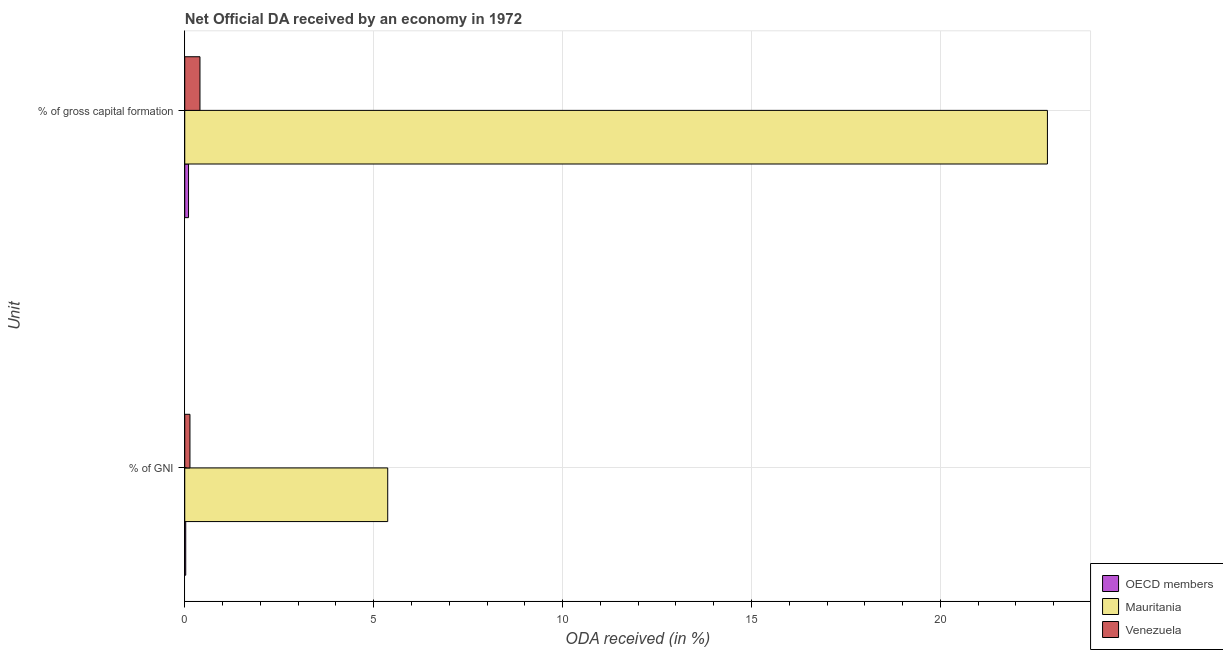How many different coloured bars are there?
Your answer should be compact. 3. How many bars are there on the 1st tick from the top?
Offer a terse response. 3. What is the label of the 2nd group of bars from the top?
Keep it short and to the point. % of GNI. What is the oda received as percentage of gross capital formation in OECD members?
Provide a succinct answer. 0.1. Across all countries, what is the maximum oda received as percentage of gross capital formation?
Your answer should be compact. 22.83. Across all countries, what is the minimum oda received as percentage of gross capital formation?
Make the answer very short. 0.1. In which country was the oda received as percentage of gni maximum?
Keep it short and to the point. Mauritania. In which country was the oda received as percentage of gross capital formation minimum?
Ensure brevity in your answer.  OECD members. What is the total oda received as percentage of gross capital formation in the graph?
Keep it short and to the point. 23.33. What is the difference between the oda received as percentage of gni in OECD members and that in Mauritania?
Provide a succinct answer. -5.35. What is the difference between the oda received as percentage of gross capital formation in Mauritania and the oda received as percentage of gni in OECD members?
Offer a very short reply. 22.81. What is the average oda received as percentage of gni per country?
Your answer should be compact. 1.85. What is the difference between the oda received as percentage of gross capital formation and oda received as percentage of gni in Venezuela?
Offer a very short reply. 0.26. What is the ratio of the oda received as percentage of gross capital formation in Mauritania to that in Venezuela?
Offer a very short reply. 56.71. Is the oda received as percentage of gross capital formation in Venezuela less than that in Mauritania?
Offer a terse response. Yes. In how many countries, is the oda received as percentage of gross capital formation greater than the average oda received as percentage of gross capital formation taken over all countries?
Offer a terse response. 1. What does the 2nd bar from the top in % of gross capital formation represents?
Provide a succinct answer. Mauritania. What does the 1st bar from the bottom in % of GNI represents?
Keep it short and to the point. OECD members. How many bars are there?
Make the answer very short. 6. Are all the bars in the graph horizontal?
Your response must be concise. Yes. How many countries are there in the graph?
Provide a short and direct response. 3. What is the difference between two consecutive major ticks on the X-axis?
Make the answer very short. 5. Are the values on the major ticks of X-axis written in scientific E-notation?
Your answer should be compact. No. How are the legend labels stacked?
Provide a short and direct response. Vertical. What is the title of the graph?
Your answer should be compact. Net Official DA received by an economy in 1972. Does "Djibouti" appear as one of the legend labels in the graph?
Your response must be concise. No. What is the label or title of the X-axis?
Provide a succinct answer. ODA received (in %). What is the label or title of the Y-axis?
Offer a terse response. Unit. What is the ODA received (in %) of OECD members in % of GNI?
Your response must be concise. 0.03. What is the ODA received (in %) in Mauritania in % of GNI?
Keep it short and to the point. 5.37. What is the ODA received (in %) in Venezuela in % of GNI?
Provide a short and direct response. 0.14. What is the ODA received (in %) in OECD members in % of gross capital formation?
Give a very brief answer. 0.1. What is the ODA received (in %) of Mauritania in % of gross capital formation?
Your answer should be compact. 22.83. What is the ODA received (in %) in Venezuela in % of gross capital formation?
Give a very brief answer. 0.4. Across all Unit, what is the maximum ODA received (in %) of OECD members?
Provide a short and direct response. 0.1. Across all Unit, what is the maximum ODA received (in %) of Mauritania?
Offer a very short reply. 22.83. Across all Unit, what is the maximum ODA received (in %) of Venezuela?
Provide a succinct answer. 0.4. Across all Unit, what is the minimum ODA received (in %) of OECD members?
Give a very brief answer. 0.03. Across all Unit, what is the minimum ODA received (in %) of Mauritania?
Your answer should be compact. 5.37. Across all Unit, what is the minimum ODA received (in %) of Venezuela?
Provide a succinct answer. 0.14. What is the total ODA received (in %) of OECD members in the graph?
Give a very brief answer. 0.13. What is the total ODA received (in %) in Mauritania in the graph?
Keep it short and to the point. 28.2. What is the total ODA received (in %) of Venezuela in the graph?
Offer a very short reply. 0.54. What is the difference between the ODA received (in %) in OECD members in % of GNI and that in % of gross capital formation?
Provide a short and direct response. -0.07. What is the difference between the ODA received (in %) in Mauritania in % of GNI and that in % of gross capital formation?
Your response must be concise. -17.46. What is the difference between the ODA received (in %) of Venezuela in % of GNI and that in % of gross capital formation?
Your answer should be compact. -0.27. What is the difference between the ODA received (in %) of OECD members in % of GNI and the ODA received (in %) of Mauritania in % of gross capital formation?
Make the answer very short. -22.81. What is the difference between the ODA received (in %) of OECD members in % of GNI and the ODA received (in %) of Venezuela in % of gross capital formation?
Your answer should be very brief. -0.38. What is the difference between the ODA received (in %) of Mauritania in % of GNI and the ODA received (in %) of Venezuela in % of gross capital formation?
Offer a very short reply. 4.97. What is the average ODA received (in %) of OECD members per Unit?
Offer a very short reply. 0.06. What is the average ODA received (in %) of Mauritania per Unit?
Provide a succinct answer. 14.1. What is the average ODA received (in %) of Venezuela per Unit?
Your answer should be very brief. 0.27. What is the difference between the ODA received (in %) of OECD members and ODA received (in %) of Mauritania in % of GNI?
Give a very brief answer. -5.35. What is the difference between the ODA received (in %) of OECD members and ODA received (in %) of Venezuela in % of GNI?
Provide a succinct answer. -0.11. What is the difference between the ODA received (in %) in Mauritania and ODA received (in %) in Venezuela in % of GNI?
Keep it short and to the point. 5.23. What is the difference between the ODA received (in %) of OECD members and ODA received (in %) of Mauritania in % of gross capital formation?
Ensure brevity in your answer.  -22.73. What is the difference between the ODA received (in %) in OECD members and ODA received (in %) in Venezuela in % of gross capital formation?
Your answer should be compact. -0.3. What is the difference between the ODA received (in %) of Mauritania and ODA received (in %) of Venezuela in % of gross capital formation?
Offer a terse response. 22.43. What is the ratio of the ODA received (in %) in OECD members in % of GNI to that in % of gross capital formation?
Ensure brevity in your answer.  0.26. What is the ratio of the ODA received (in %) in Mauritania in % of GNI to that in % of gross capital formation?
Keep it short and to the point. 0.24. What is the ratio of the ODA received (in %) in Venezuela in % of GNI to that in % of gross capital formation?
Make the answer very short. 0.34. What is the difference between the highest and the second highest ODA received (in %) of OECD members?
Your answer should be very brief. 0.07. What is the difference between the highest and the second highest ODA received (in %) of Mauritania?
Your response must be concise. 17.46. What is the difference between the highest and the second highest ODA received (in %) of Venezuela?
Provide a short and direct response. 0.27. What is the difference between the highest and the lowest ODA received (in %) of OECD members?
Keep it short and to the point. 0.07. What is the difference between the highest and the lowest ODA received (in %) of Mauritania?
Ensure brevity in your answer.  17.46. What is the difference between the highest and the lowest ODA received (in %) in Venezuela?
Keep it short and to the point. 0.27. 